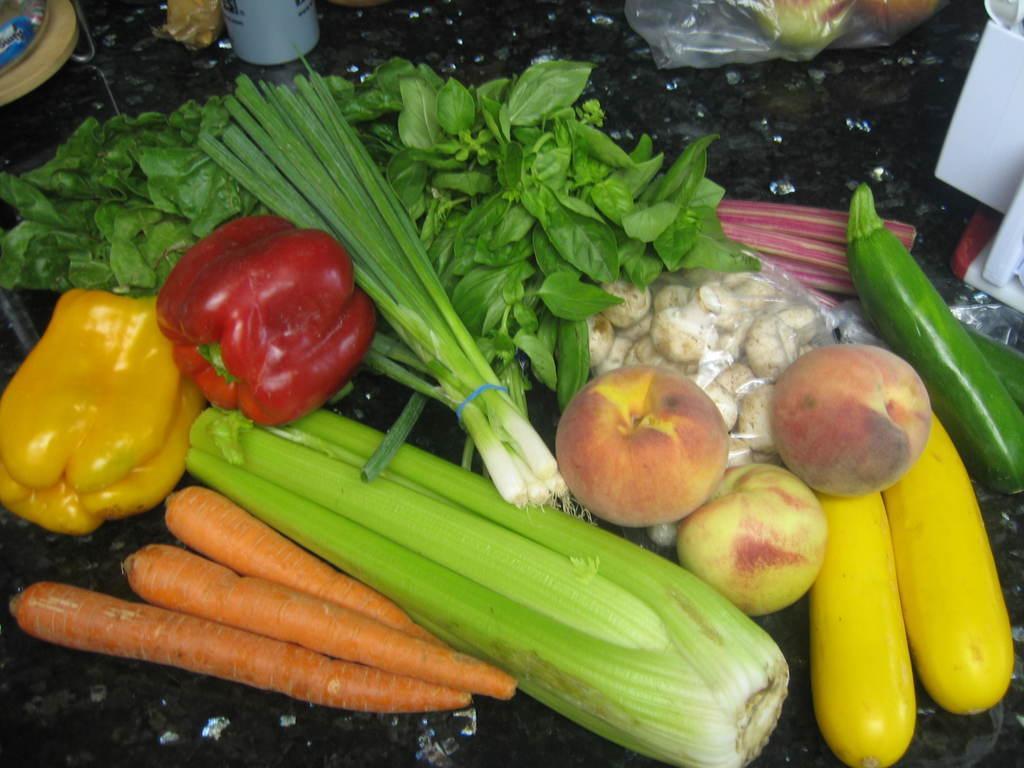How would you summarize this image in a sentence or two? In this image there is a table and we can see bell peppers, leafy vegetables , mushrooms, apples, zucchini, corn, carrots, cover and some objects placed on the table. 